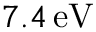<formula> <loc_0><loc_0><loc_500><loc_500>7 . 4 \, e V</formula> 